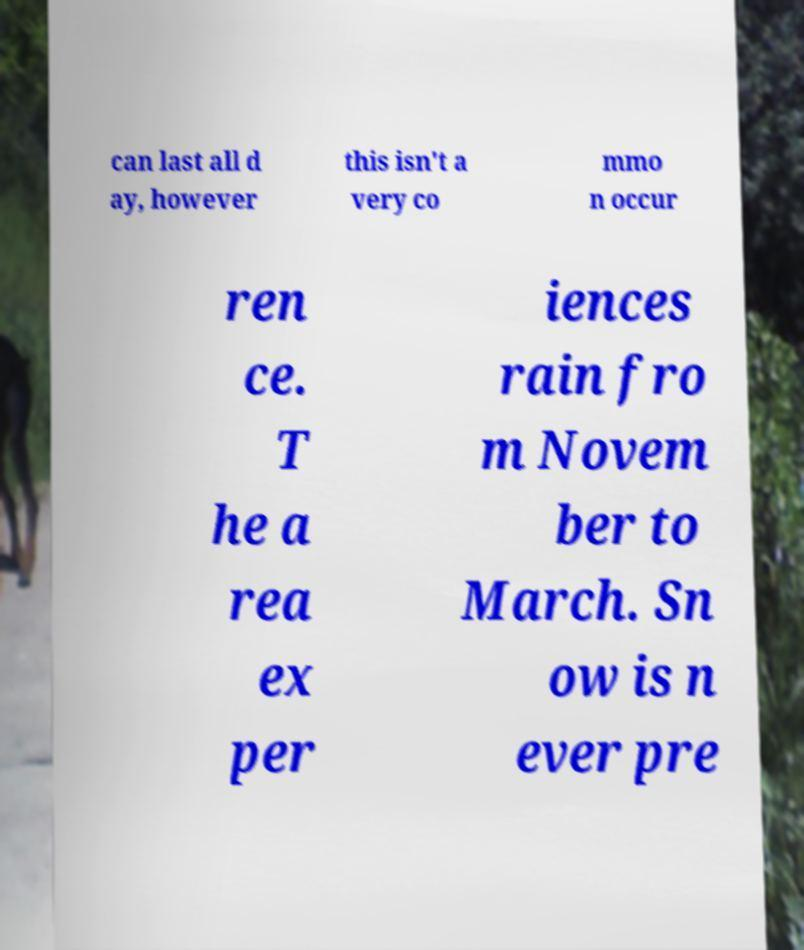For documentation purposes, I need the text within this image transcribed. Could you provide that? can last all d ay, however this isn't a very co mmo n occur ren ce. T he a rea ex per iences rain fro m Novem ber to March. Sn ow is n ever pre 